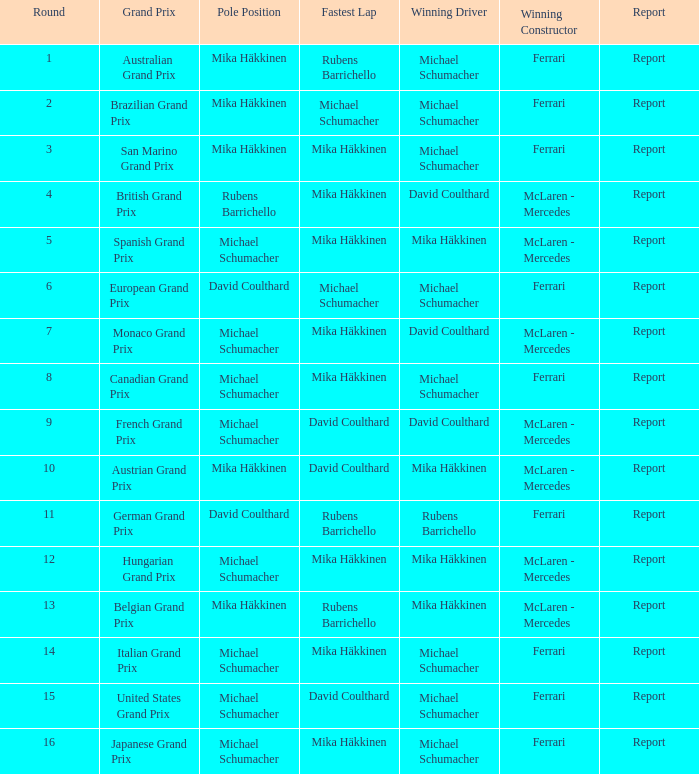What was the summary of the belgian grand prix? Report. 